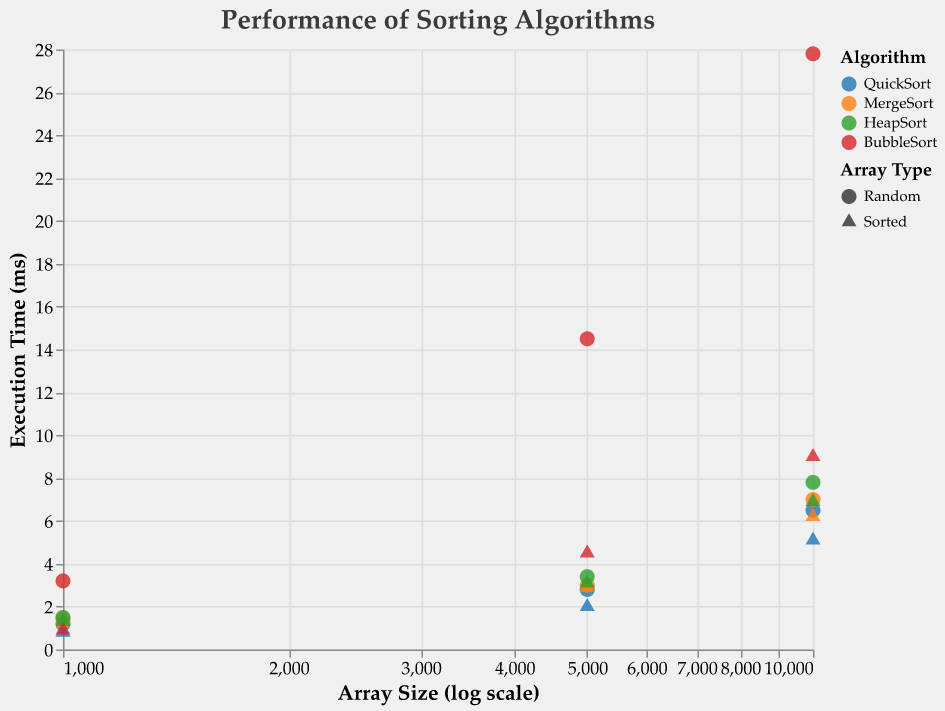What is the title of the figure? The title is displayed at the top of the figure within the title area.
Answer: Performance of Sorting Algorithms Which algorithm has the highest execution time for a random array of size 10,000? Locate the data points for all algorithms with a random array of size 10,000 on the x-axis and compare their execution times on the y-axis. The highest point corresponds to BubbleSort.
Answer: BubbleSort How does the execution time of QuickSort compare between a sorted array and a random array of size 1,000? Find the points for QuickSort with array size 1,000 for both sorted and random arrays. Compare the corresponding y-values. The execution time for QuickSort with a sorted array is lower (0.8 ms) compared to a random array (1.2 ms).
Answer: Lower for sorted array Which array type does BubbleSort perform better on, for arrays of size 5,000? Compare the data points for BubbleSort with an array size of 5,000 for both sorted and random array types. The execution time is significantly lower for the sorted array (4.5 ms vs. 14.5 ms).
Answer: Sorted What is the execution time difference between MergeSort and HeapSort for a sorted array of size 5,000? Find the points on the chart for MergeSort and HeapSort for sorted arrays of size 5,000. Calculate the difference in their y-values, which are 2.9 ms for MergeSort and 3.1 ms for HeapSort, respectively. The difference is 0.2 ms.
Answer: 0.2 ms Which algorithm is the most consistent across different array types for an array size of 10,000? Analyze the execution times of different algorithms for both sorted and random arrays of size 10,000. QuickSort shows smaller variations (6.5 ms for random, 5.1 ms for sorted) compared to other algorithms with higher variations.
Answer: QuickSort What is the trend in execution times as array size increases for MergeSort on random arrays? Look at the points representing MergeSort for random arrays at different sizes (1,000, 5,000, and 10,000). Observe that the y-values (execution times) increase with array size (1.4 ms, 3.0 ms, 7.0 ms).
Answer: Increases Which algorithm has the lowest execution time for a sorted array of size 1,000? Find the data points corresponding to all algorithms for a sorted array of size 1,000 and identify the one with the lowest y-value, which is QuickSort at 0.8 ms.
Answer: QuickSort Between BubbleSort and HeapSort, which has a higher variability in execution time across different array sizes for random arrays? Compare the range of execution times for BubbleSort (3.2 ms to 27.8 ms) and HeapSort (1.5 ms to 7.8 ms) on random arrays. BubbleSort shows a higher range, indicating greater variability.
Answer: BubbleSort 